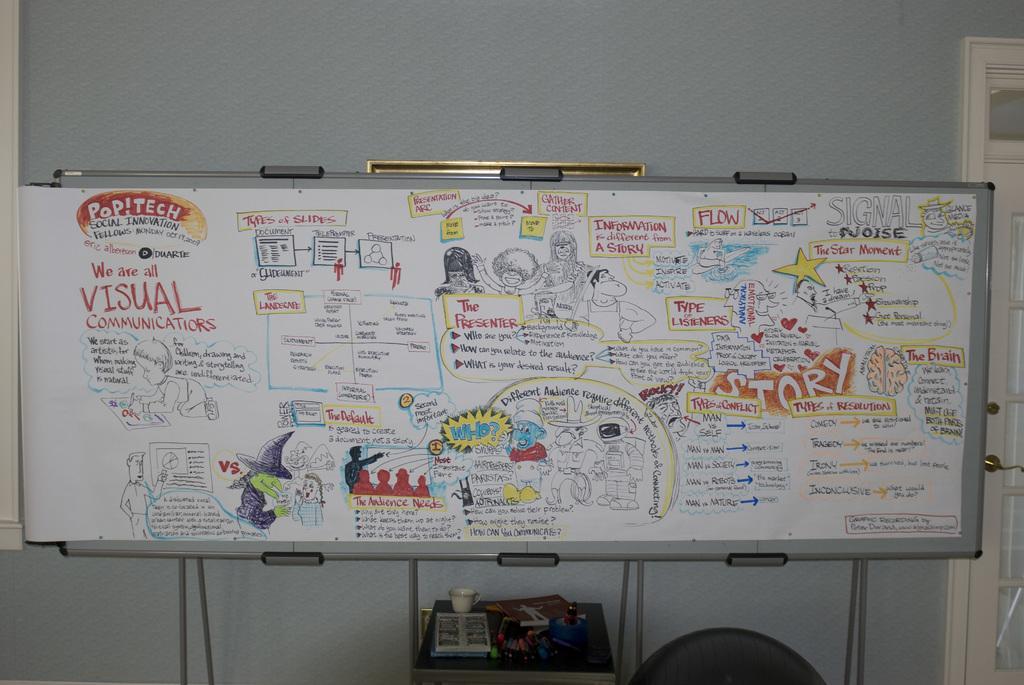Can you describe this image briefly? We can see board,on this board we can see drawing of people and text,under the board we can see objects on the table. Background we can see wall and door. 